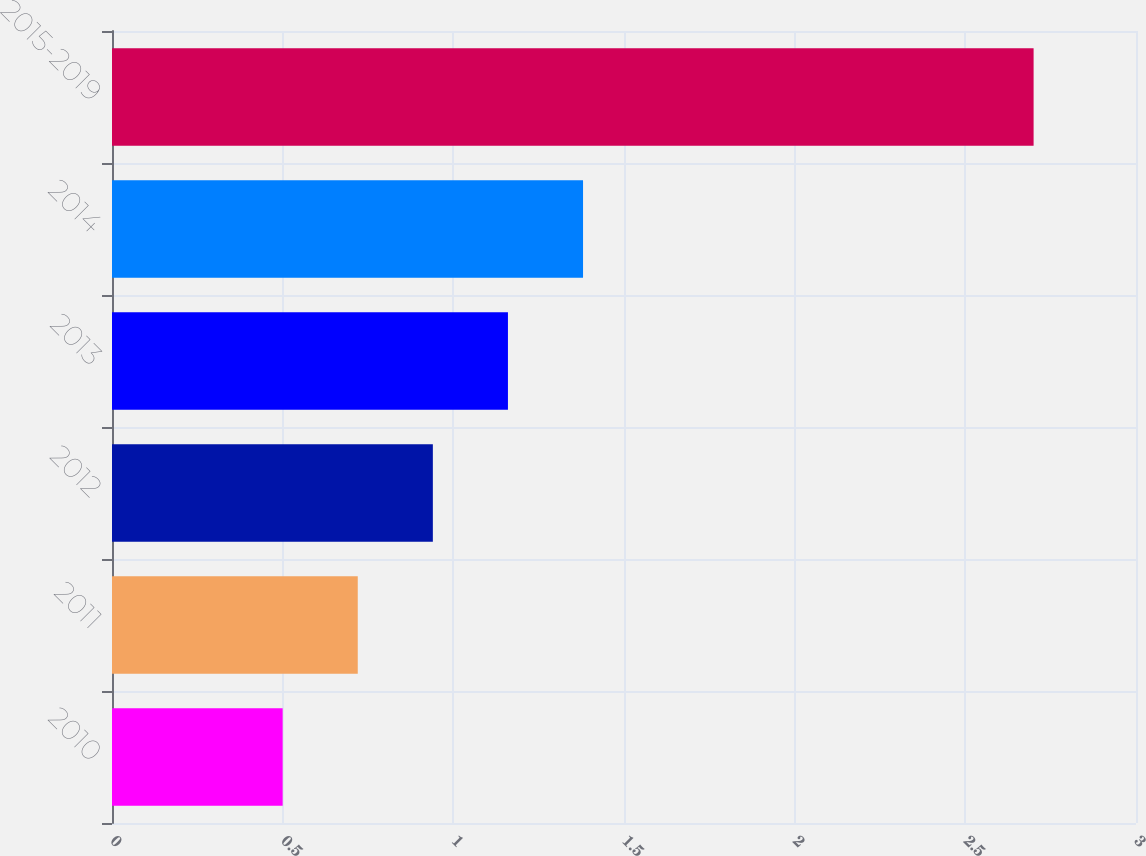Convert chart. <chart><loc_0><loc_0><loc_500><loc_500><bar_chart><fcel>2010<fcel>2011<fcel>2012<fcel>2013<fcel>2014<fcel>2015-2019<nl><fcel>0.5<fcel>0.72<fcel>0.94<fcel>1.16<fcel>1.38<fcel>2.7<nl></chart> 